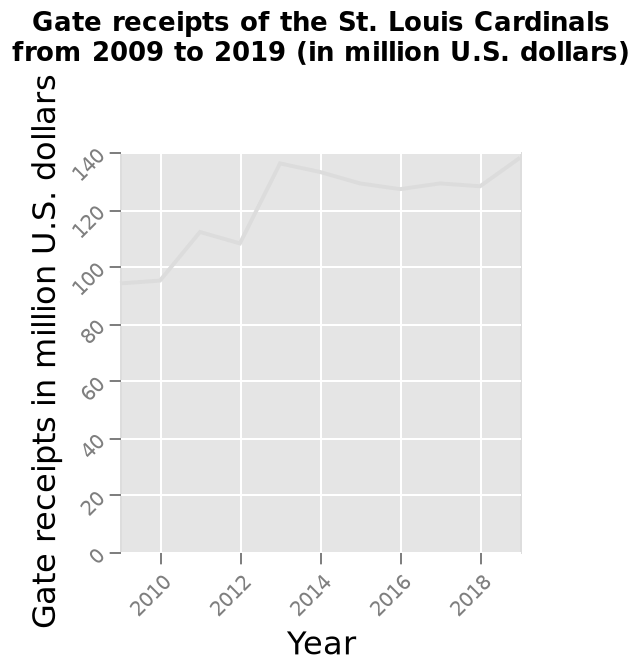<image>
What was the trend in hate receipts from mid 2012 onwards?  From mid 2012 onwards, hate receipts have remained relatively stable. Did hate receipts significantly fluctuate from mid 2012 onwards? No. From mid 2012 onwards, hate receipts have remained relatively stable. 